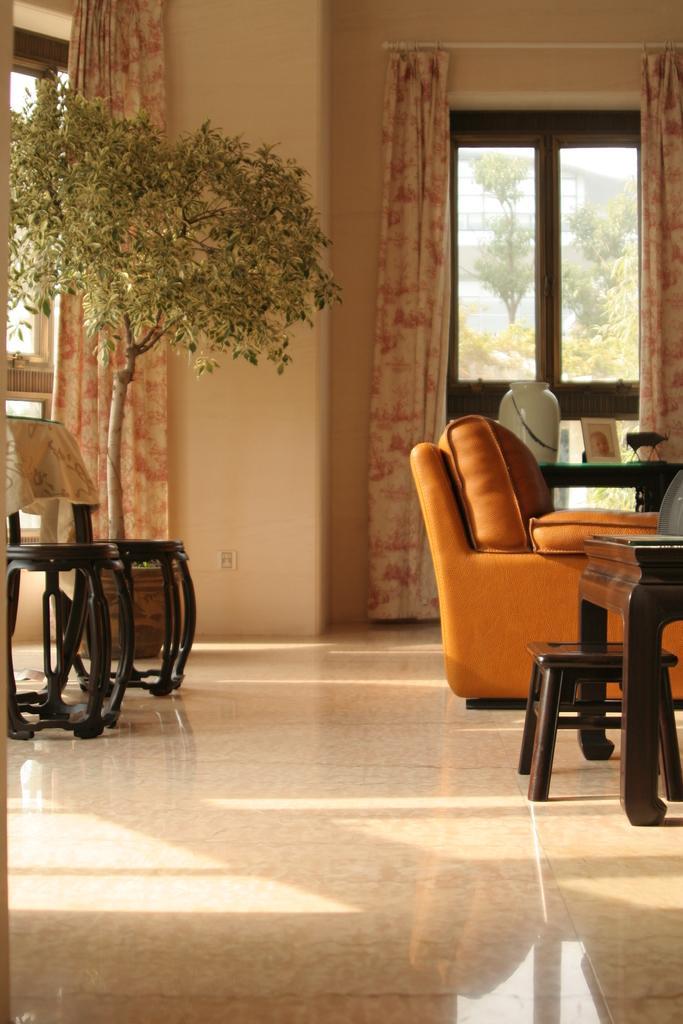How would you summarize this image in a sentence or two? In the image on the right we can see sofa,table on table some objects,stool. On the left we can see one more table,two stools. Back we can see curtain,wall,window and trees. 